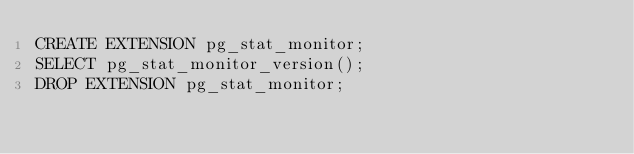<code> <loc_0><loc_0><loc_500><loc_500><_SQL_>CREATE EXTENSION pg_stat_monitor;
SELECT pg_stat_monitor_version();
DROP EXTENSION pg_stat_monitor;
</code> 